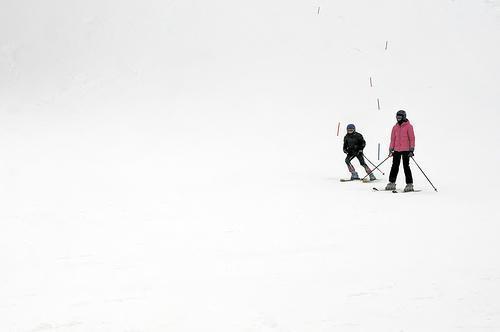Why are sticks stuck into the snow?
Select the accurate answer and provide explanation: 'Answer: answer
Rationale: rationale.'
Options: Tradition, visibility, guidance, style. Answer: guidance.
Rationale: The sticks help guide the people through the snow. 